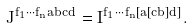Convert formula to latex. <formula><loc_0><loc_0><loc_500><loc_500>J ^ { f _ { 1 } \cdots f _ { n } a b c d } = I ^ { f _ { 1 } \cdots f _ { n } [ a [ c b ] d ] } .</formula> 